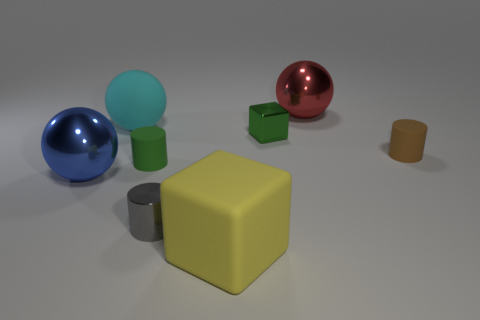Subtract all big blue spheres. How many spheres are left? 2 Add 1 big cyan things. How many objects exist? 9 Subtract all red spheres. How many spheres are left? 2 Subtract 1 cubes. How many cubes are left? 1 Subtract all large yellow matte cylinders. Subtract all large things. How many objects are left? 4 Add 7 big yellow matte cubes. How many big yellow matte cubes are left? 8 Add 2 small brown cylinders. How many small brown cylinders exist? 3 Subtract 0 gray blocks. How many objects are left? 8 Subtract all cubes. How many objects are left? 6 Subtract all blue cylinders. Subtract all red blocks. How many cylinders are left? 3 